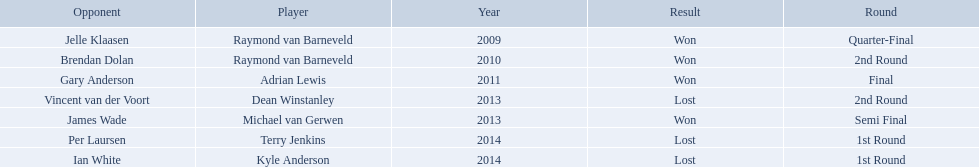Who are the players listed? Raymond van Barneveld, Raymond van Barneveld, Adrian Lewis, Dean Winstanley, Michael van Gerwen, Terry Jenkins, Kyle Anderson. Which of these players played in 2011? Adrian Lewis. 